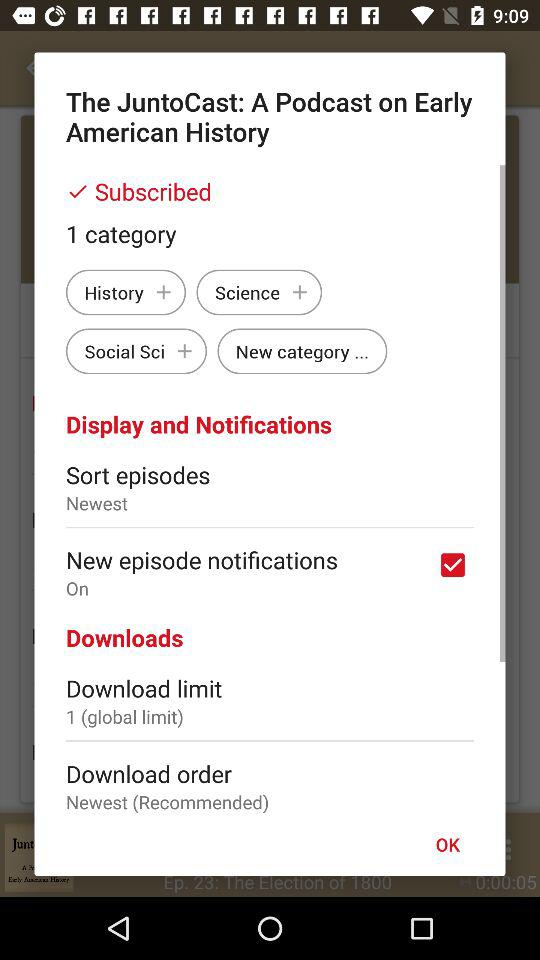What is the status of "New episode notifications"? The status of "New episode notifications" is "on". 